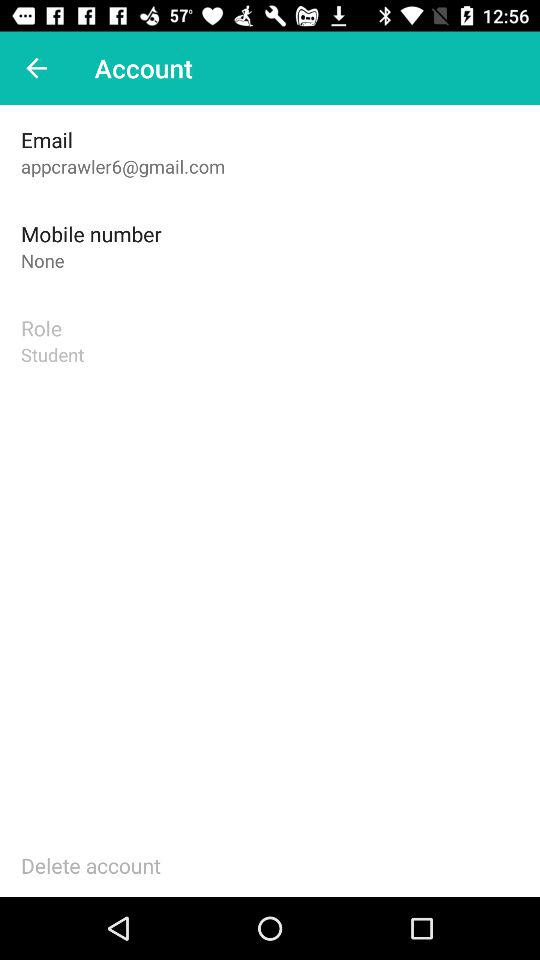Where is the user located?
When the provided information is insufficient, respond with <no answer>. <no answer> 